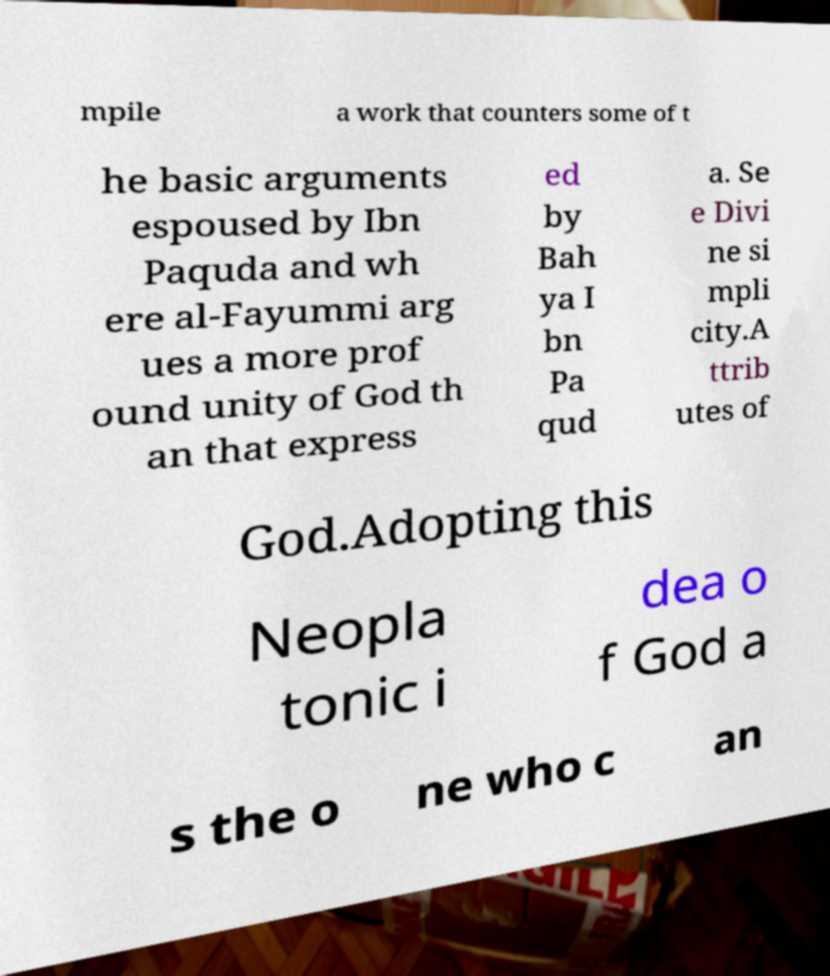Could you extract and type out the text from this image? mpile a work that counters some of t he basic arguments espoused by Ibn Paquda and wh ere al-Fayummi arg ues a more prof ound unity of God th an that express ed by Bah ya I bn Pa qud a. Se e Divi ne si mpli city.A ttrib utes of God.Adopting this Neopla tonic i dea o f God a s the o ne who c an 